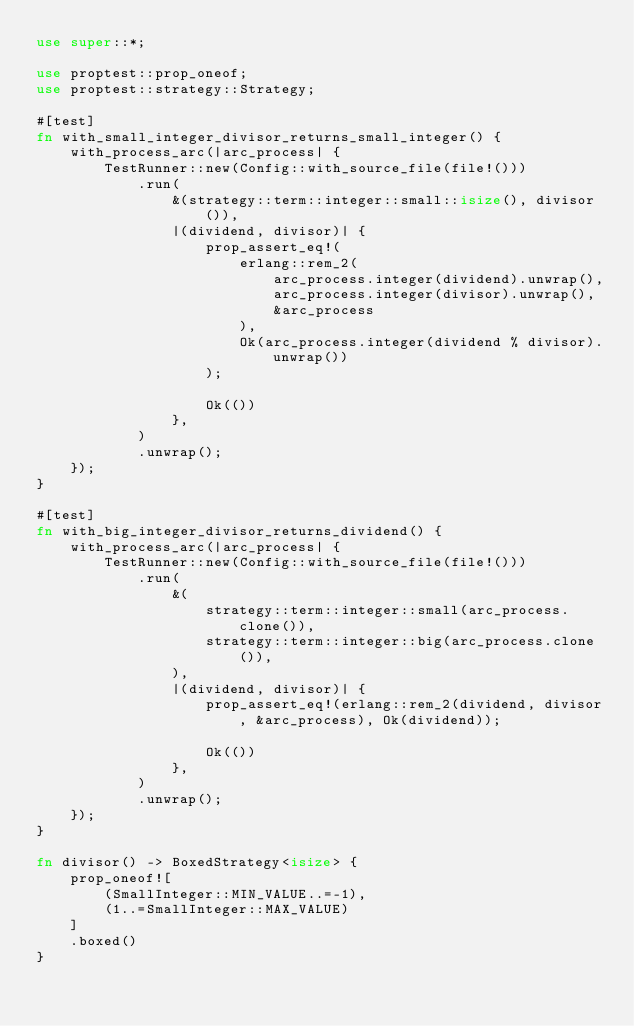<code> <loc_0><loc_0><loc_500><loc_500><_Rust_>use super::*;

use proptest::prop_oneof;
use proptest::strategy::Strategy;

#[test]
fn with_small_integer_divisor_returns_small_integer() {
    with_process_arc(|arc_process| {
        TestRunner::new(Config::with_source_file(file!()))
            .run(
                &(strategy::term::integer::small::isize(), divisor()),
                |(dividend, divisor)| {
                    prop_assert_eq!(
                        erlang::rem_2(
                            arc_process.integer(dividend).unwrap(),
                            arc_process.integer(divisor).unwrap(),
                            &arc_process
                        ),
                        Ok(arc_process.integer(dividend % divisor).unwrap())
                    );

                    Ok(())
                },
            )
            .unwrap();
    });
}

#[test]
fn with_big_integer_divisor_returns_dividend() {
    with_process_arc(|arc_process| {
        TestRunner::new(Config::with_source_file(file!()))
            .run(
                &(
                    strategy::term::integer::small(arc_process.clone()),
                    strategy::term::integer::big(arc_process.clone()),
                ),
                |(dividend, divisor)| {
                    prop_assert_eq!(erlang::rem_2(dividend, divisor, &arc_process), Ok(dividend));

                    Ok(())
                },
            )
            .unwrap();
    });
}

fn divisor() -> BoxedStrategy<isize> {
    prop_oneof![
        (SmallInteger::MIN_VALUE..=-1),
        (1..=SmallInteger::MAX_VALUE)
    ]
    .boxed()
}
</code> 